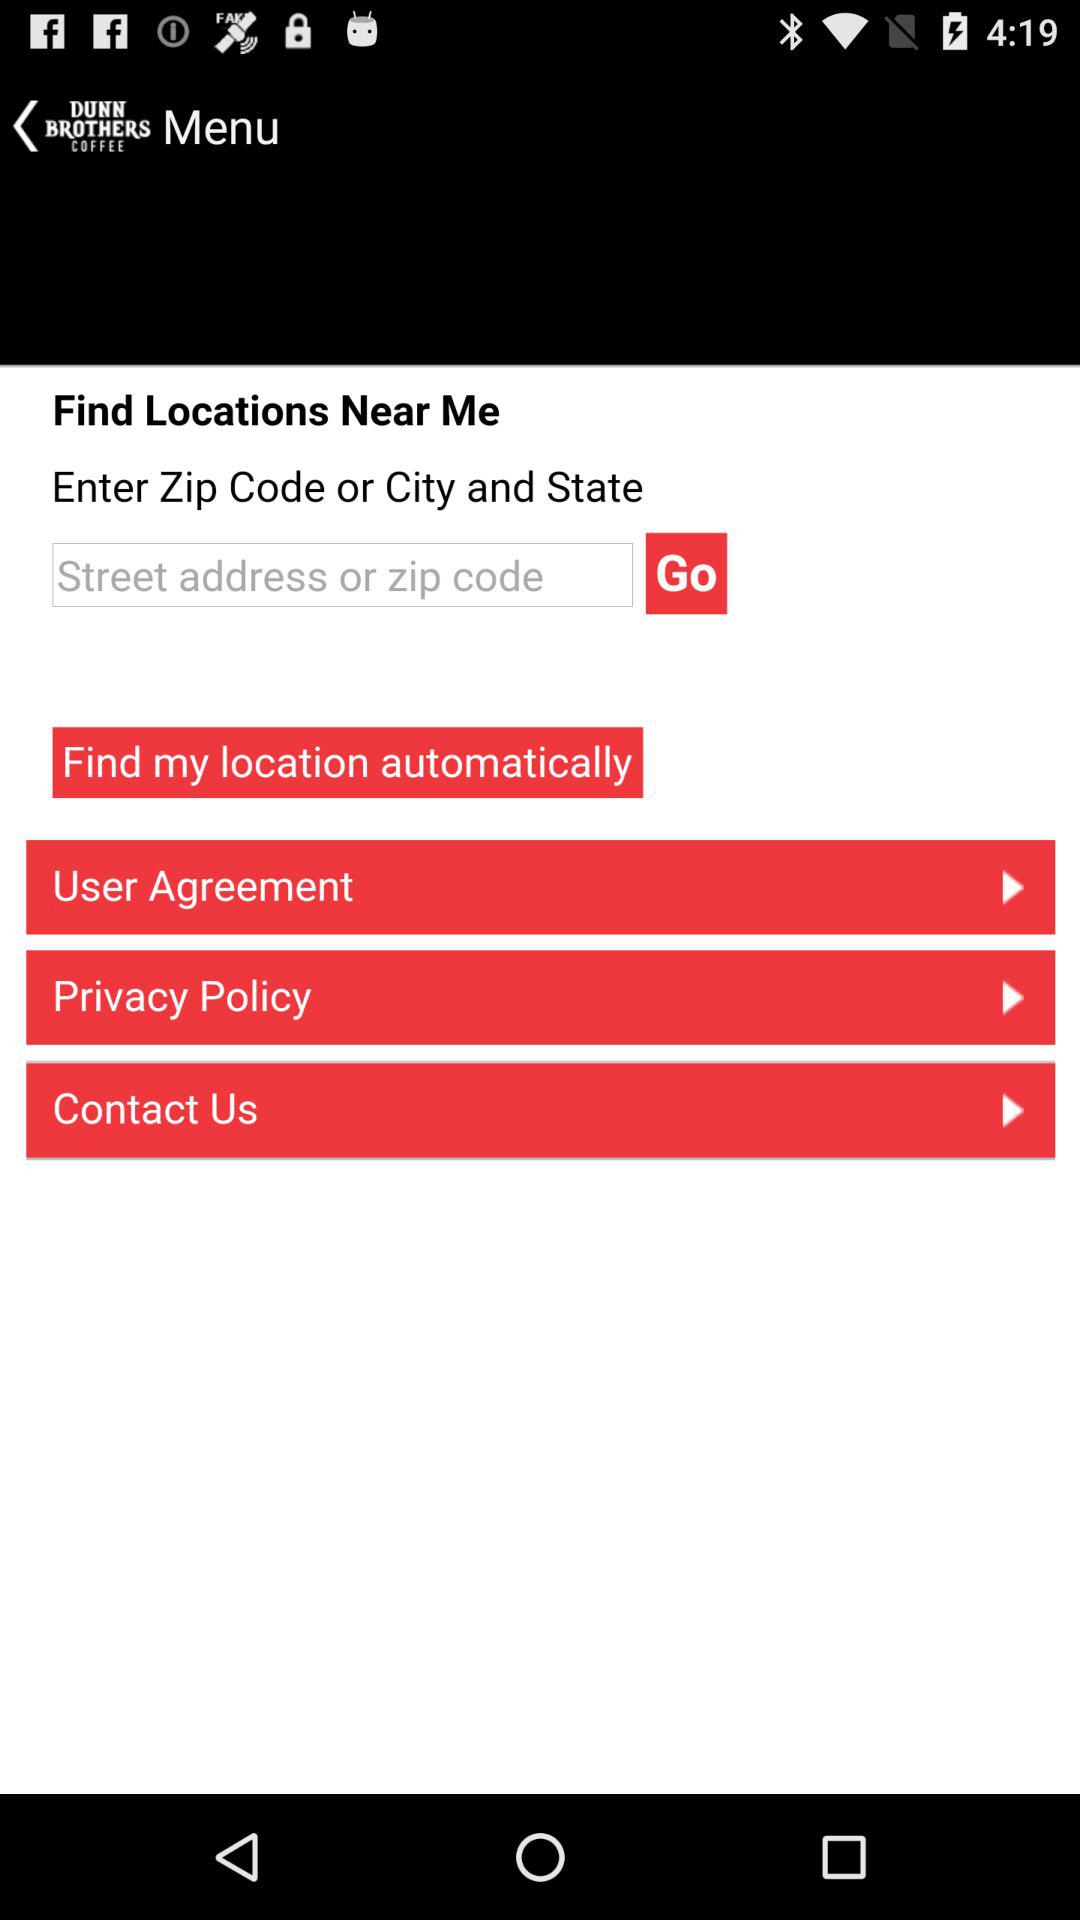What is the app name? The app name is "DUNN BROTHERS COFFEE". 